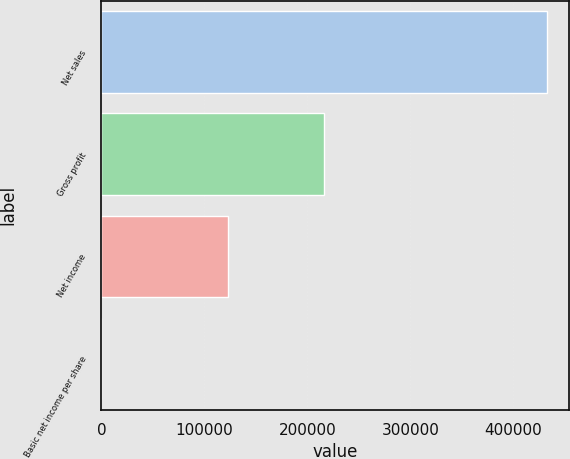Convert chart. <chart><loc_0><loc_0><loc_500><loc_500><bar_chart><fcel>Net sales<fcel>Gross profit<fcel>Net income<fcel>Basic net income per share<nl><fcel>432468<fcel>216284<fcel>123286<fcel>0.57<nl></chart> 